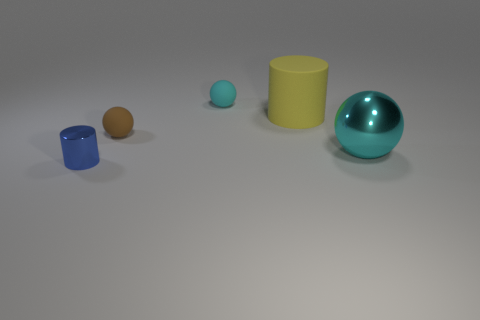Is the number of rubber spheres greater than the number of big cyan spheres?
Ensure brevity in your answer.  Yes. There is a blue thing that is in front of the yellow cylinder; is it the same shape as the brown thing?
Offer a terse response. No. How many metallic objects are either small cyan things or tiny objects?
Give a very brief answer. 1. Is there a big yellow cylinder that has the same material as the tiny cyan thing?
Offer a very short reply. Yes. What material is the blue object?
Your response must be concise. Metal. There is a metal thing that is to the left of the cyan ball in front of the object behind the yellow rubber thing; what shape is it?
Keep it short and to the point. Cylinder. Is the number of big balls behind the yellow rubber cylinder greater than the number of objects?
Ensure brevity in your answer.  No. Do the tiny blue thing and the tiny object to the right of the brown object have the same shape?
Ensure brevity in your answer.  No. The thing that is the same color as the big sphere is what shape?
Offer a terse response. Sphere. How many tiny cyan matte things are behind the small matte thing that is in front of the big thing behind the metal sphere?
Offer a terse response. 1. 